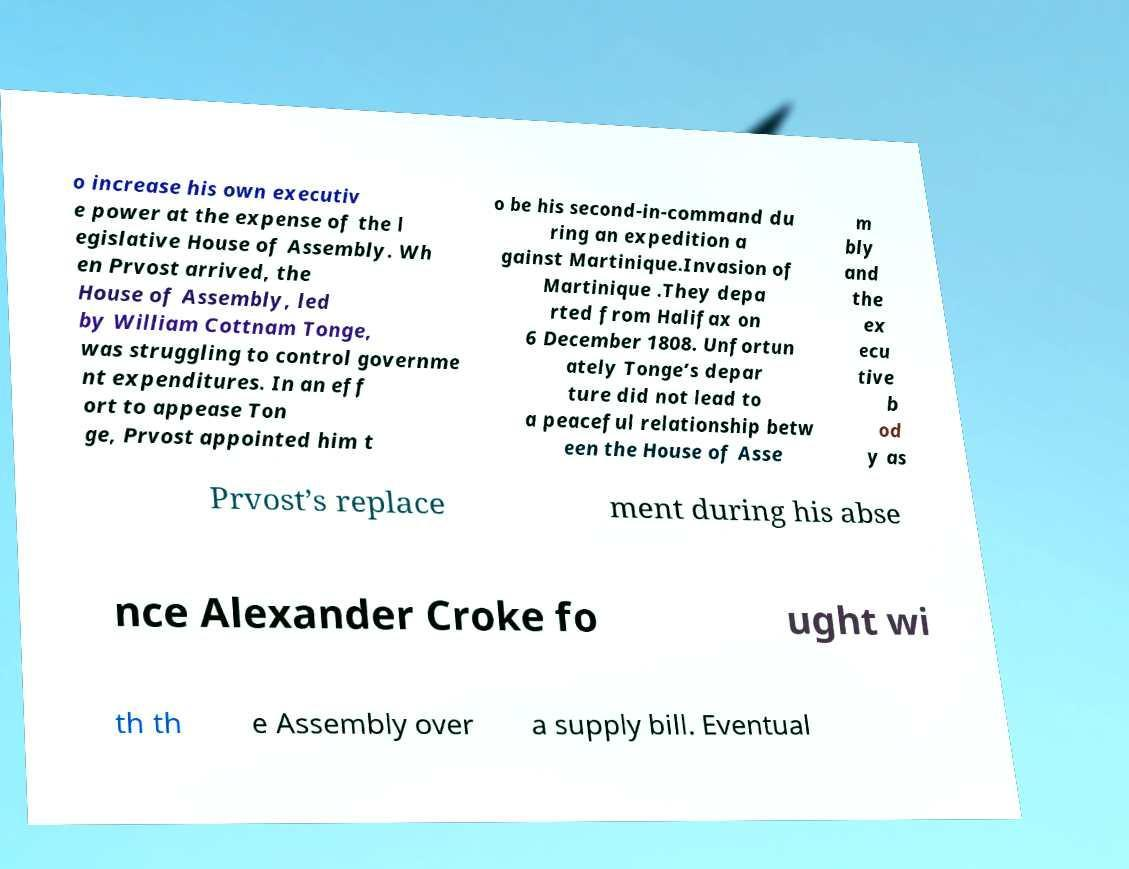Could you extract and type out the text from this image? o increase his own executiv e power at the expense of the l egislative House of Assembly. Wh en Prvost arrived, the House of Assembly, led by William Cottnam Tonge, was struggling to control governme nt expenditures. In an eff ort to appease Ton ge, Prvost appointed him t o be his second-in-command du ring an expedition a gainst Martinique.Invasion of Martinique .They depa rted from Halifax on 6 December 1808. Unfortun ately Tonge’s depar ture did not lead to a peaceful relationship betw een the House of Asse m bly and the ex ecu tive b od y as Prvost’s replace ment during his abse nce Alexander Croke fo ught wi th th e Assembly over a supply bill. Eventual 